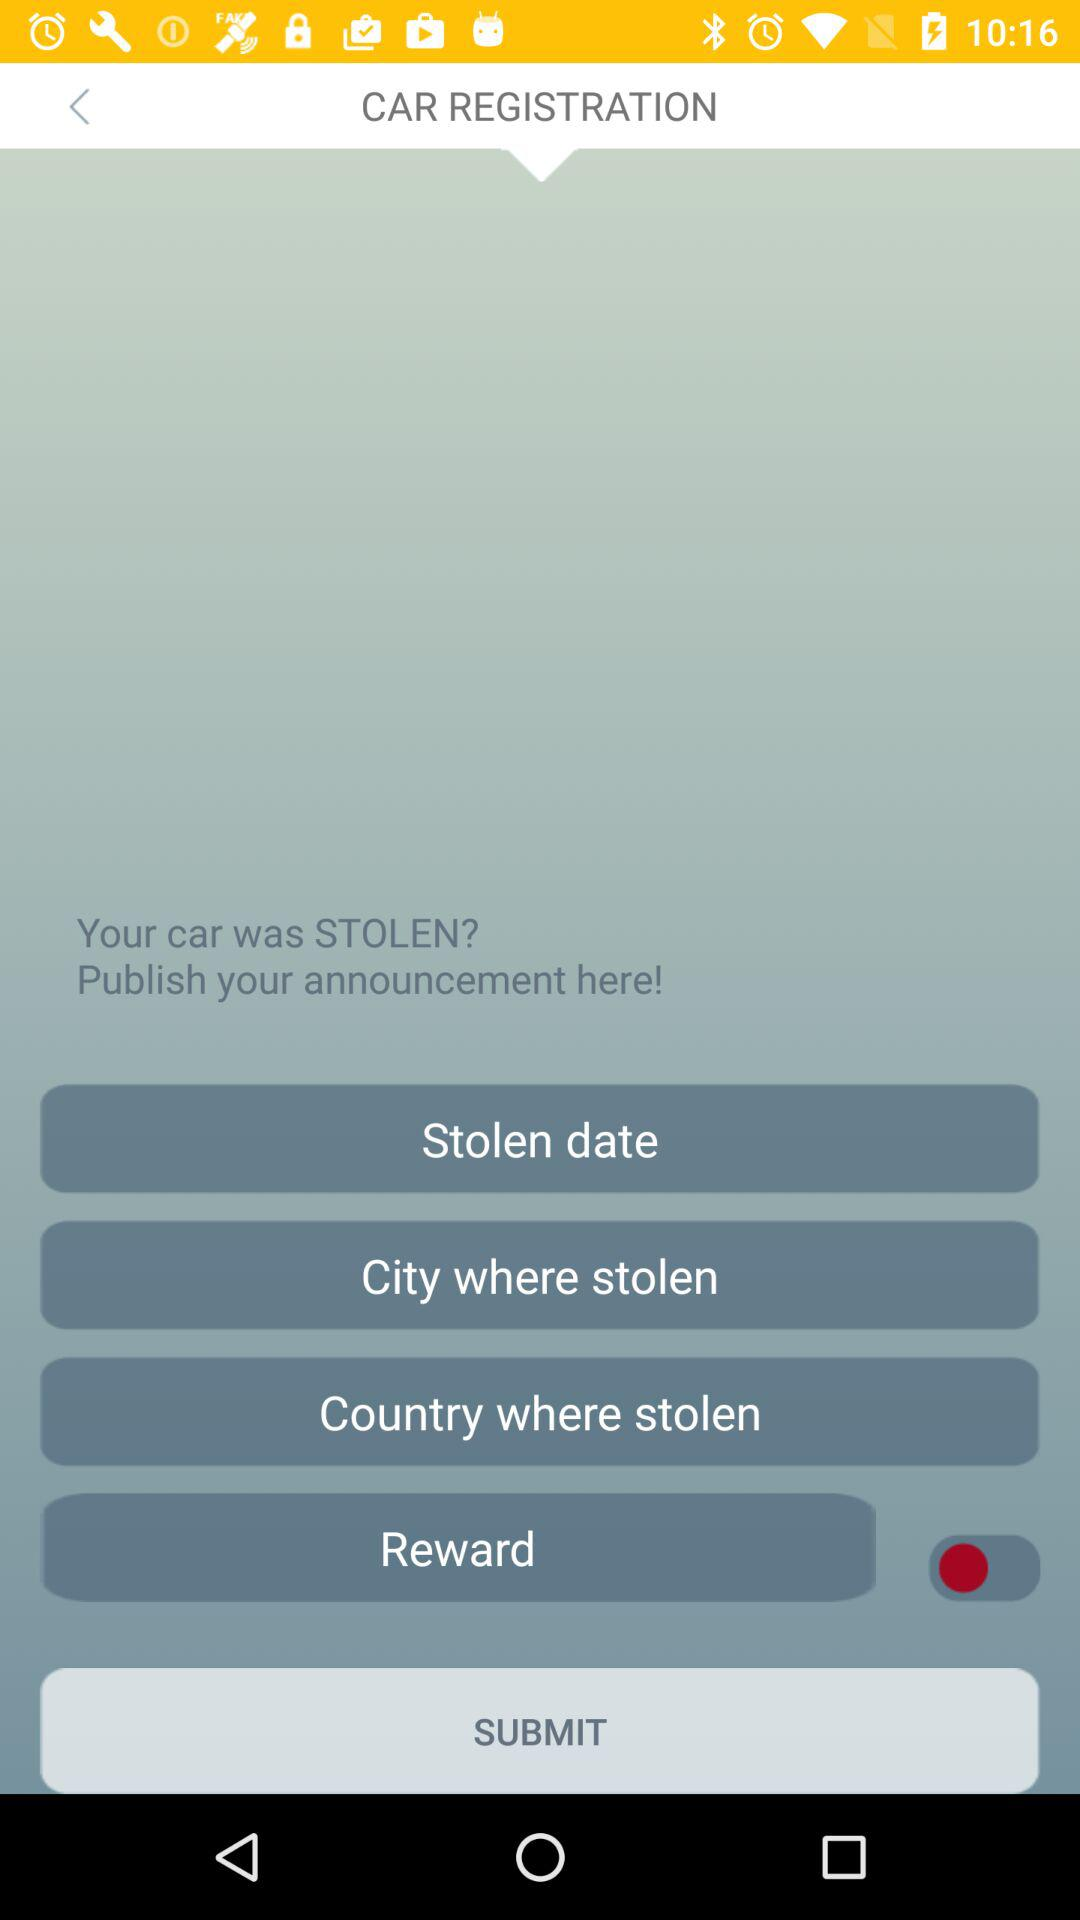What is the status of "Reward"? The status is "off". 